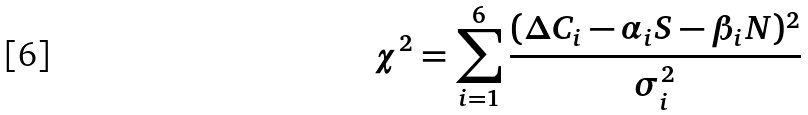<formula> <loc_0><loc_0><loc_500><loc_500>\chi ^ { 2 } = \sum _ { i = 1 } ^ { 6 } \frac { ( \Delta C _ { i } - \alpha _ { i } S - \beta _ { i } N ) ^ { 2 } } { \sigma _ { i } ^ { 2 } }</formula> 